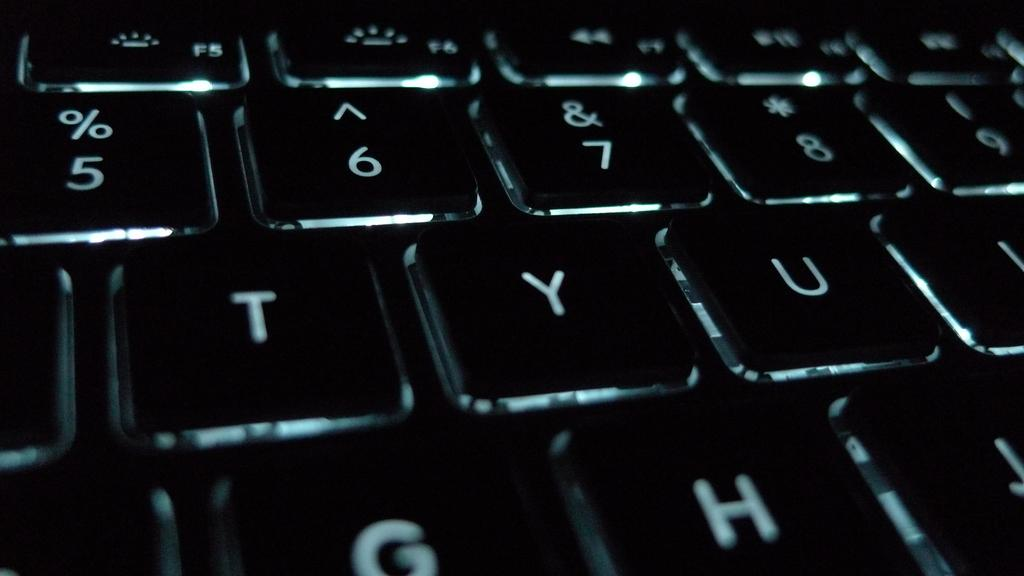What musical instrument is visible in the image? There is a keyboard in the image. Where is the sink located in the image? There is no sink present in the image. What type of sweater is the person wearing while playing the keyboard in the image? There is no person or sweater visible in the image; only the keyboard is present. 